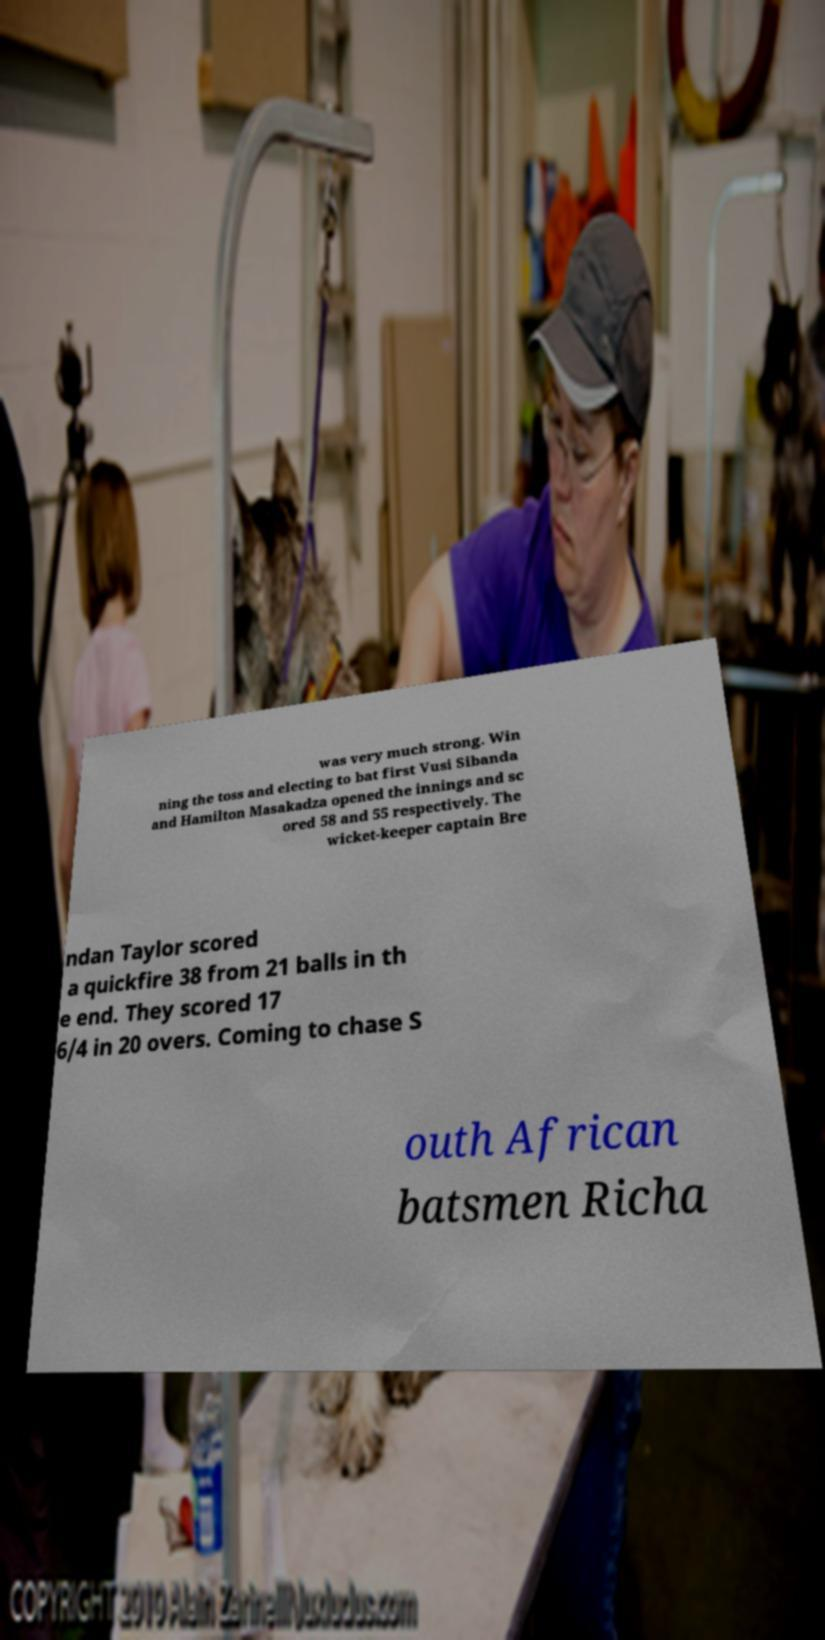What messages or text are displayed in this image? I need them in a readable, typed format. was very much strong. Win ning the toss and electing to bat first Vusi Sibanda and Hamilton Masakadza opened the innings and sc ored 58 and 55 respectively. The wicket-keeper captain Bre ndan Taylor scored a quickfire 38 from 21 balls in th e end. They scored 17 6/4 in 20 overs. Coming to chase S outh African batsmen Richa 